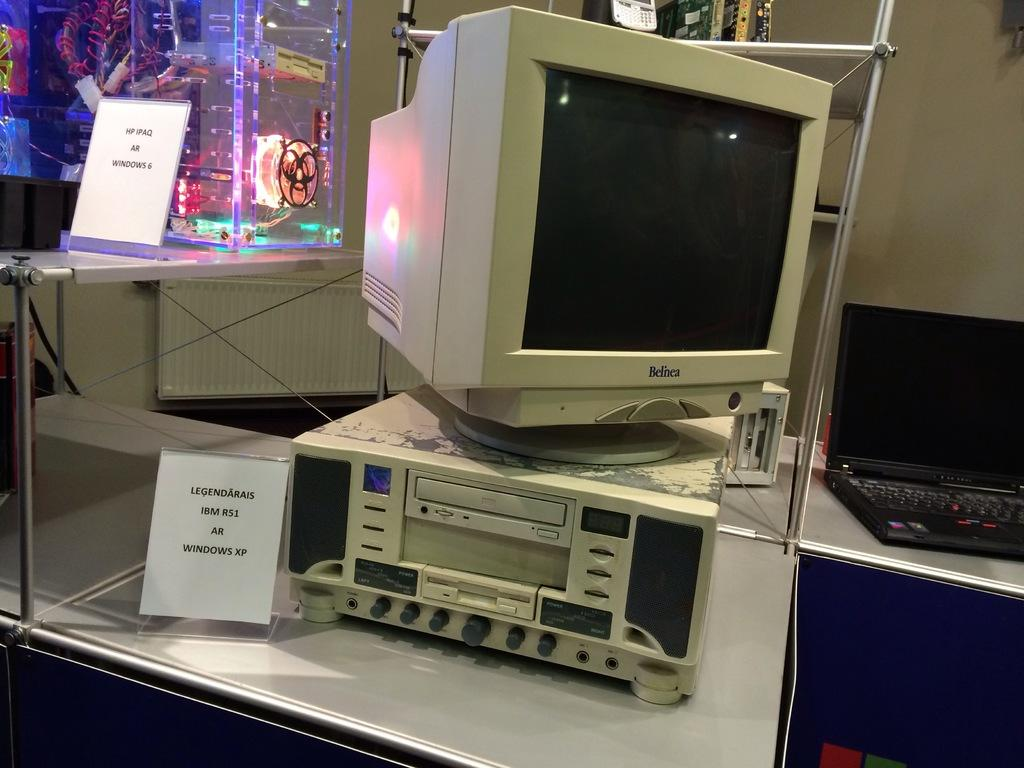<image>
Share a concise interpretation of the image provided. A Belnea brand computer monitor is atop of a computer running Windows XP. 